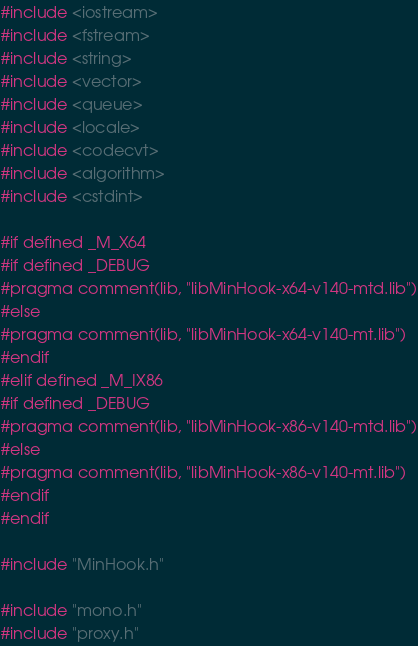Convert code to text. <code><loc_0><loc_0><loc_500><loc_500><_C_>
#include <iostream>
#include <fstream>
#include <string>
#include <vector>
#include <queue>
#include <locale>
#include <codecvt>
#include <algorithm>
#include <cstdint>

#if defined _M_X64
#if defined _DEBUG
#pragma comment(lib, "libMinHook-x64-v140-mtd.lib")
#else
#pragma comment(lib, "libMinHook-x64-v140-mt.lib")
#endif
#elif defined _M_IX86
#if defined _DEBUG
#pragma comment(lib, "libMinHook-x86-v140-mtd.lib")
#else
#pragma comment(lib, "libMinHook-x86-v140-mt.lib")
#endif
#endif

#include "MinHook.h"

#include "mono.h"
#include "proxy.h"</code> 